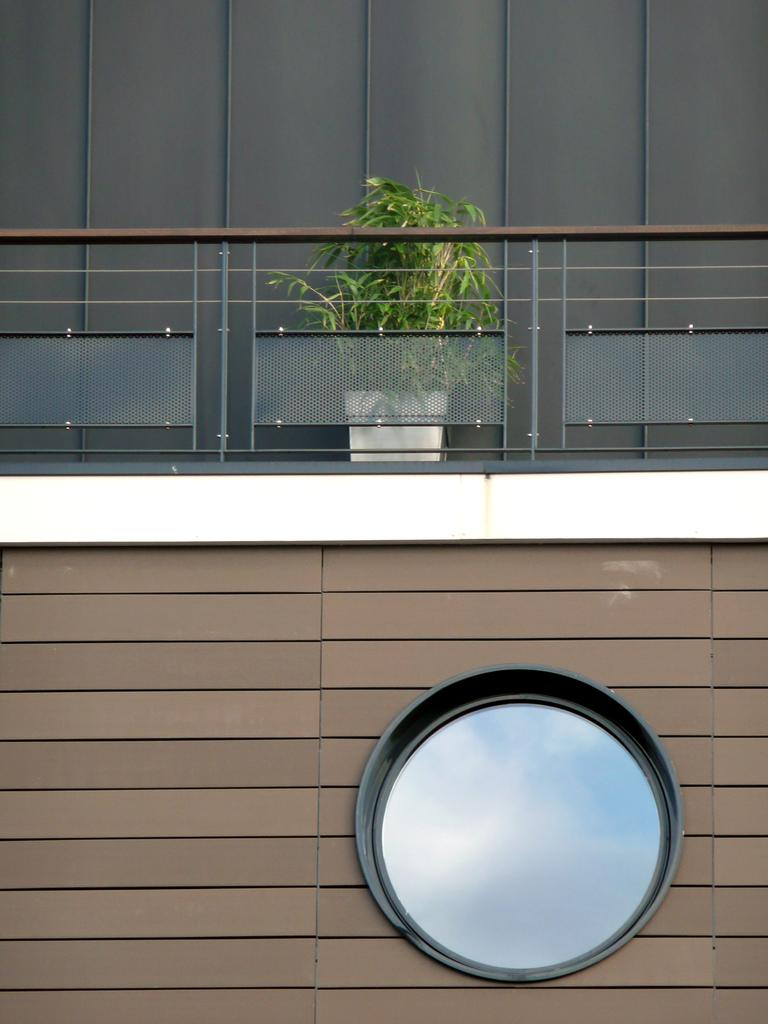What is located in the foreground of the image? There is a wall in the foreground of the image. What is on the wall? There is a circular structure on the wall. What is on top of the wall? There is railing on top of the wall. What type of vegetation can be seen in the image? There is a plant visible in the image. What is the color of the wall in the background? There is a black wall in the background of the image. How many fish are swimming in the shade in the image? There are no fish or shaded areas present in the image. 